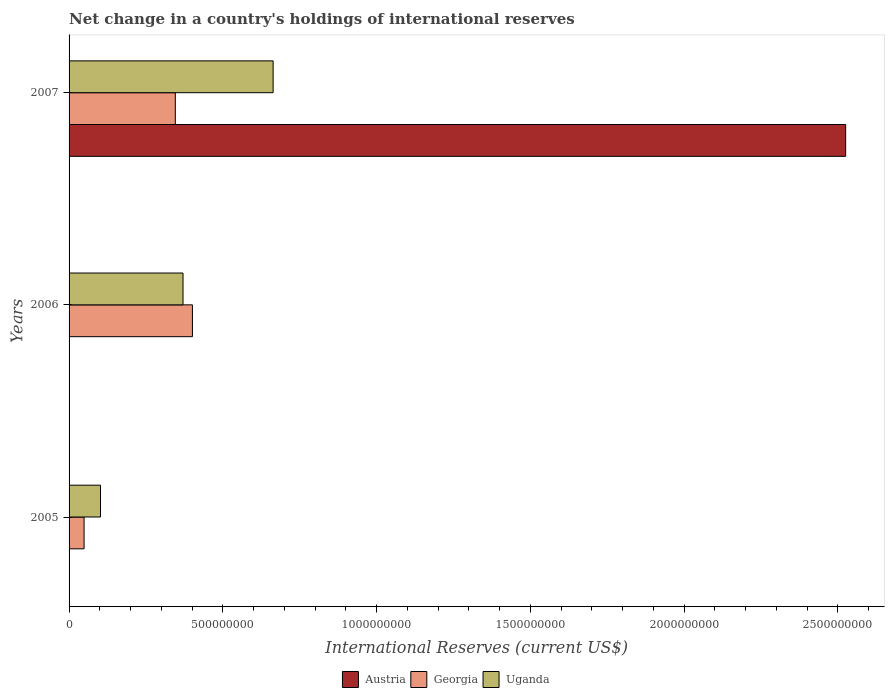How many different coloured bars are there?
Your answer should be very brief. 3. Are the number of bars on each tick of the Y-axis equal?
Offer a very short reply. No. How many bars are there on the 1st tick from the top?
Make the answer very short. 3. How many bars are there on the 3rd tick from the bottom?
Provide a succinct answer. 3. What is the label of the 2nd group of bars from the top?
Make the answer very short. 2006. In how many cases, is the number of bars for a given year not equal to the number of legend labels?
Keep it short and to the point. 2. What is the international reserves in Georgia in 2005?
Your answer should be very brief. 4.88e+07. Across all years, what is the maximum international reserves in Uganda?
Provide a succinct answer. 6.64e+08. Across all years, what is the minimum international reserves in Austria?
Offer a very short reply. 0. What is the total international reserves in Austria in the graph?
Ensure brevity in your answer.  2.53e+09. What is the difference between the international reserves in Uganda in 2005 and that in 2007?
Keep it short and to the point. -5.61e+08. What is the difference between the international reserves in Uganda in 2006 and the international reserves in Austria in 2007?
Your answer should be compact. -2.15e+09. What is the average international reserves in Austria per year?
Give a very brief answer. 8.42e+08. In the year 2006, what is the difference between the international reserves in Georgia and international reserves in Uganda?
Ensure brevity in your answer.  3.06e+07. In how many years, is the international reserves in Uganda greater than 2100000000 US$?
Offer a very short reply. 0. What is the ratio of the international reserves in Georgia in 2006 to that in 2007?
Keep it short and to the point. 1.16. What is the difference between the highest and the second highest international reserves in Uganda?
Keep it short and to the point. 2.93e+08. What is the difference between the highest and the lowest international reserves in Austria?
Make the answer very short. 2.53e+09. In how many years, is the international reserves in Georgia greater than the average international reserves in Georgia taken over all years?
Offer a terse response. 2. Is it the case that in every year, the sum of the international reserves in Austria and international reserves in Georgia is greater than the international reserves in Uganda?
Offer a very short reply. No. How many bars are there?
Your response must be concise. 7. Are all the bars in the graph horizontal?
Make the answer very short. Yes. What is the difference between two consecutive major ticks on the X-axis?
Offer a terse response. 5.00e+08. Are the values on the major ticks of X-axis written in scientific E-notation?
Give a very brief answer. No. Does the graph contain any zero values?
Your answer should be compact. Yes. How many legend labels are there?
Make the answer very short. 3. What is the title of the graph?
Give a very brief answer. Net change in a country's holdings of international reserves. Does "Kosovo" appear as one of the legend labels in the graph?
Ensure brevity in your answer.  No. What is the label or title of the X-axis?
Give a very brief answer. International Reserves (current US$). What is the International Reserves (current US$) in Georgia in 2005?
Your answer should be very brief. 4.88e+07. What is the International Reserves (current US$) of Uganda in 2005?
Make the answer very short. 1.02e+08. What is the International Reserves (current US$) in Georgia in 2006?
Offer a very short reply. 4.01e+08. What is the International Reserves (current US$) in Uganda in 2006?
Make the answer very short. 3.70e+08. What is the International Reserves (current US$) in Austria in 2007?
Your answer should be very brief. 2.53e+09. What is the International Reserves (current US$) of Georgia in 2007?
Ensure brevity in your answer.  3.45e+08. What is the International Reserves (current US$) of Uganda in 2007?
Ensure brevity in your answer.  6.64e+08. Across all years, what is the maximum International Reserves (current US$) of Austria?
Ensure brevity in your answer.  2.53e+09. Across all years, what is the maximum International Reserves (current US$) in Georgia?
Give a very brief answer. 4.01e+08. Across all years, what is the maximum International Reserves (current US$) of Uganda?
Offer a very short reply. 6.64e+08. Across all years, what is the minimum International Reserves (current US$) in Georgia?
Your answer should be compact. 4.88e+07. Across all years, what is the minimum International Reserves (current US$) of Uganda?
Your answer should be very brief. 1.02e+08. What is the total International Reserves (current US$) in Austria in the graph?
Offer a terse response. 2.53e+09. What is the total International Reserves (current US$) of Georgia in the graph?
Make the answer very short. 7.95e+08. What is the total International Reserves (current US$) of Uganda in the graph?
Offer a very short reply. 1.14e+09. What is the difference between the International Reserves (current US$) of Georgia in 2005 and that in 2006?
Keep it short and to the point. -3.52e+08. What is the difference between the International Reserves (current US$) in Uganda in 2005 and that in 2006?
Give a very brief answer. -2.68e+08. What is the difference between the International Reserves (current US$) of Georgia in 2005 and that in 2007?
Keep it short and to the point. -2.97e+08. What is the difference between the International Reserves (current US$) of Uganda in 2005 and that in 2007?
Keep it short and to the point. -5.61e+08. What is the difference between the International Reserves (current US$) of Georgia in 2006 and that in 2007?
Offer a very short reply. 5.57e+07. What is the difference between the International Reserves (current US$) of Uganda in 2006 and that in 2007?
Offer a very short reply. -2.93e+08. What is the difference between the International Reserves (current US$) in Georgia in 2005 and the International Reserves (current US$) in Uganda in 2006?
Provide a succinct answer. -3.22e+08. What is the difference between the International Reserves (current US$) of Georgia in 2005 and the International Reserves (current US$) of Uganda in 2007?
Your response must be concise. -6.15e+08. What is the difference between the International Reserves (current US$) of Georgia in 2006 and the International Reserves (current US$) of Uganda in 2007?
Your response must be concise. -2.62e+08. What is the average International Reserves (current US$) in Austria per year?
Provide a succinct answer. 8.42e+08. What is the average International Reserves (current US$) in Georgia per year?
Keep it short and to the point. 2.65e+08. What is the average International Reserves (current US$) in Uganda per year?
Your answer should be compact. 3.79e+08. In the year 2005, what is the difference between the International Reserves (current US$) of Georgia and International Reserves (current US$) of Uganda?
Provide a short and direct response. -5.34e+07. In the year 2006, what is the difference between the International Reserves (current US$) in Georgia and International Reserves (current US$) in Uganda?
Your answer should be compact. 3.06e+07. In the year 2007, what is the difference between the International Reserves (current US$) of Austria and International Reserves (current US$) of Georgia?
Your response must be concise. 2.18e+09. In the year 2007, what is the difference between the International Reserves (current US$) of Austria and International Reserves (current US$) of Uganda?
Provide a short and direct response. 1.86e+09. In the year 2007, what is the difference between the International Reserves (current US$) of Georgia and International Reserves (current US$) of Uganda?
Offer a very short reply. -3.18e+08. What is the ratio of the International Reserves (current US$) of Georgia in 2005 to that in 2006?
Ensure brevity in your answer.  0.12. What is the ratio of the International Reserves (current US$) of Uganda in 2005 to that in 2006?
Give a very brief answer. 0.28. What is the ratio of the International Reserves (current US$) in Georgia in 2005 to that in 2007?
Offer a very short reply. 0.14. What is the ratio of the International Reserves (current US$) of Uganda in 2005 to that in 2007?
Offer a very short reply. 0.15. What is the ratio of the International Reserves (current US$) of Georgia in 2006 to that in 2007?
Offer a very short reply. 1.16. What is the ratio of the International Reserves (current US$) of Uganda in 2006 to that in 2007?
Offer a very short reply. 0.56. What is the difference between the highest and the second highest International Reserves (current US$) of Georgia?
Make the answer very short. 5.57e+07. What is the difference between the highest and the second highest International Reserves (current US$) in Uganda?
Offer a very short reply. 2.93e+08. What is the difference between the highest and the lowest International Reserves (current US$) of Austria?
Give a very brief answer. 2.53e+09. What is the difference between the highest and the lowest International Reserves (current US$) of Georgia?
Your answer should be compact. 3.52e+08. What is the difference between the highest and the lowest International Reserves (current US$) of Uganda?
Offer a very short reply. 5.61e+08. 